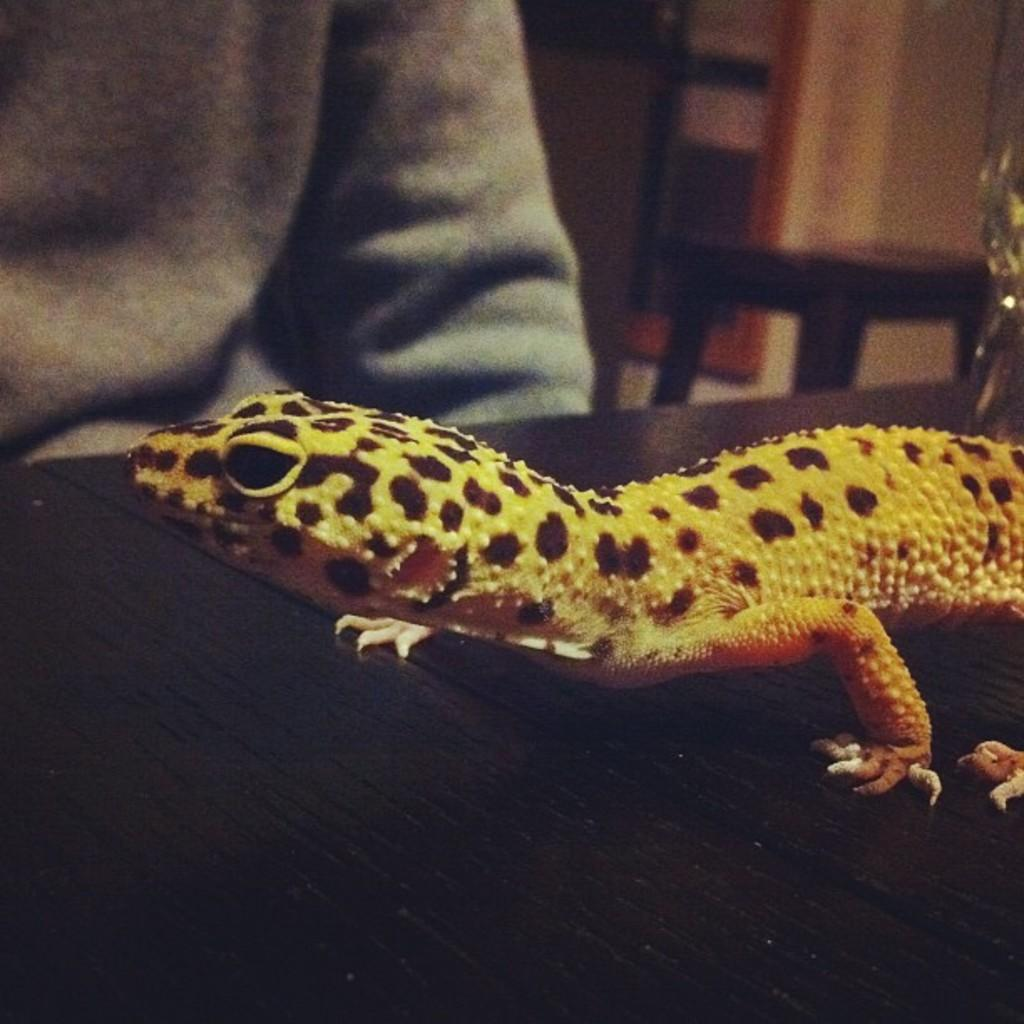What animal is present on the black surface in the image? There is a lizard on a black surface in the image. Who or what is in front of the lizard? There is a person sitting in front of the lizard. What object is behind the person? There is a table behind the person. How would you describe the background of the image? The background of the image is blurred. How many cans of soda are on the table in the image? There is no mention of soda or cans in the image; it only features a lizard, a person, and a table. 